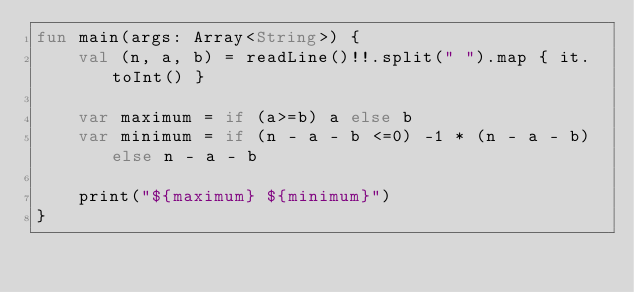<code> <loc_0><loc_0><loc_500><loc_500><_Kotlin_>fun main(args: Array<String>) {
    val (n, a, b) = readLine()!!.split(" ").map { it.toInt() }

    var maximum = if (a>=b) a else b
    var minimum = if (n - a - b <=0) -1 * (n - a - b) else n - a - b

    print("${maximum} ${minimum}")
}</code> 